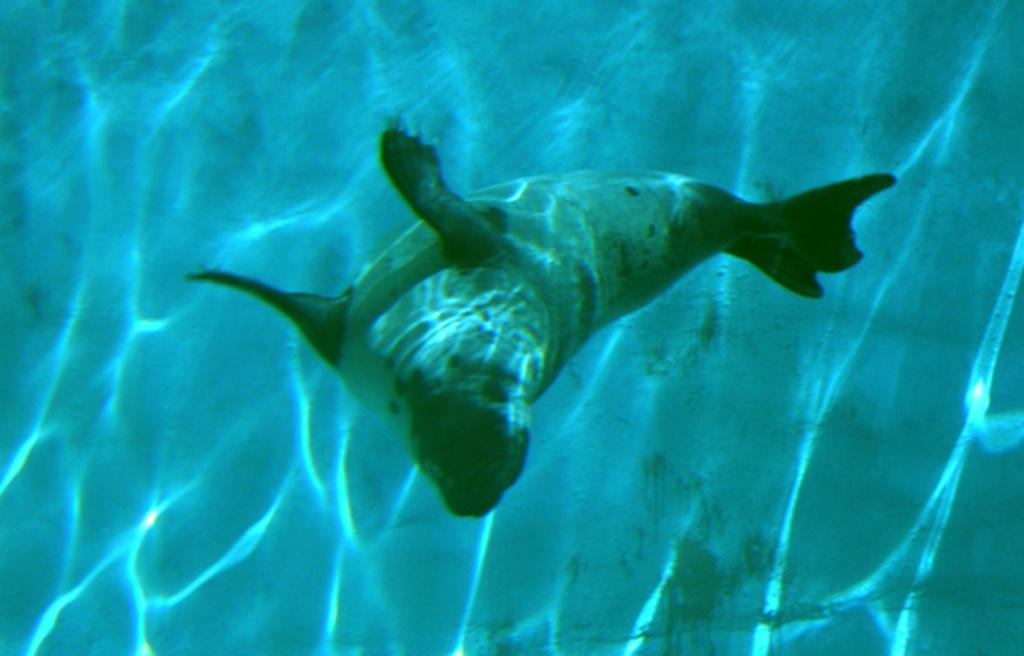What type of animal can be seen in the image? There is a seal in the water in the image. Where is the seal located in the image? The seal is in the water in the image. What type of car is parked next to the seal in the image? There is no car present in the image; it features a seal in the water. What is the relation between the seal and the person in the image? There is no person present in the image, only a seal in the water. 